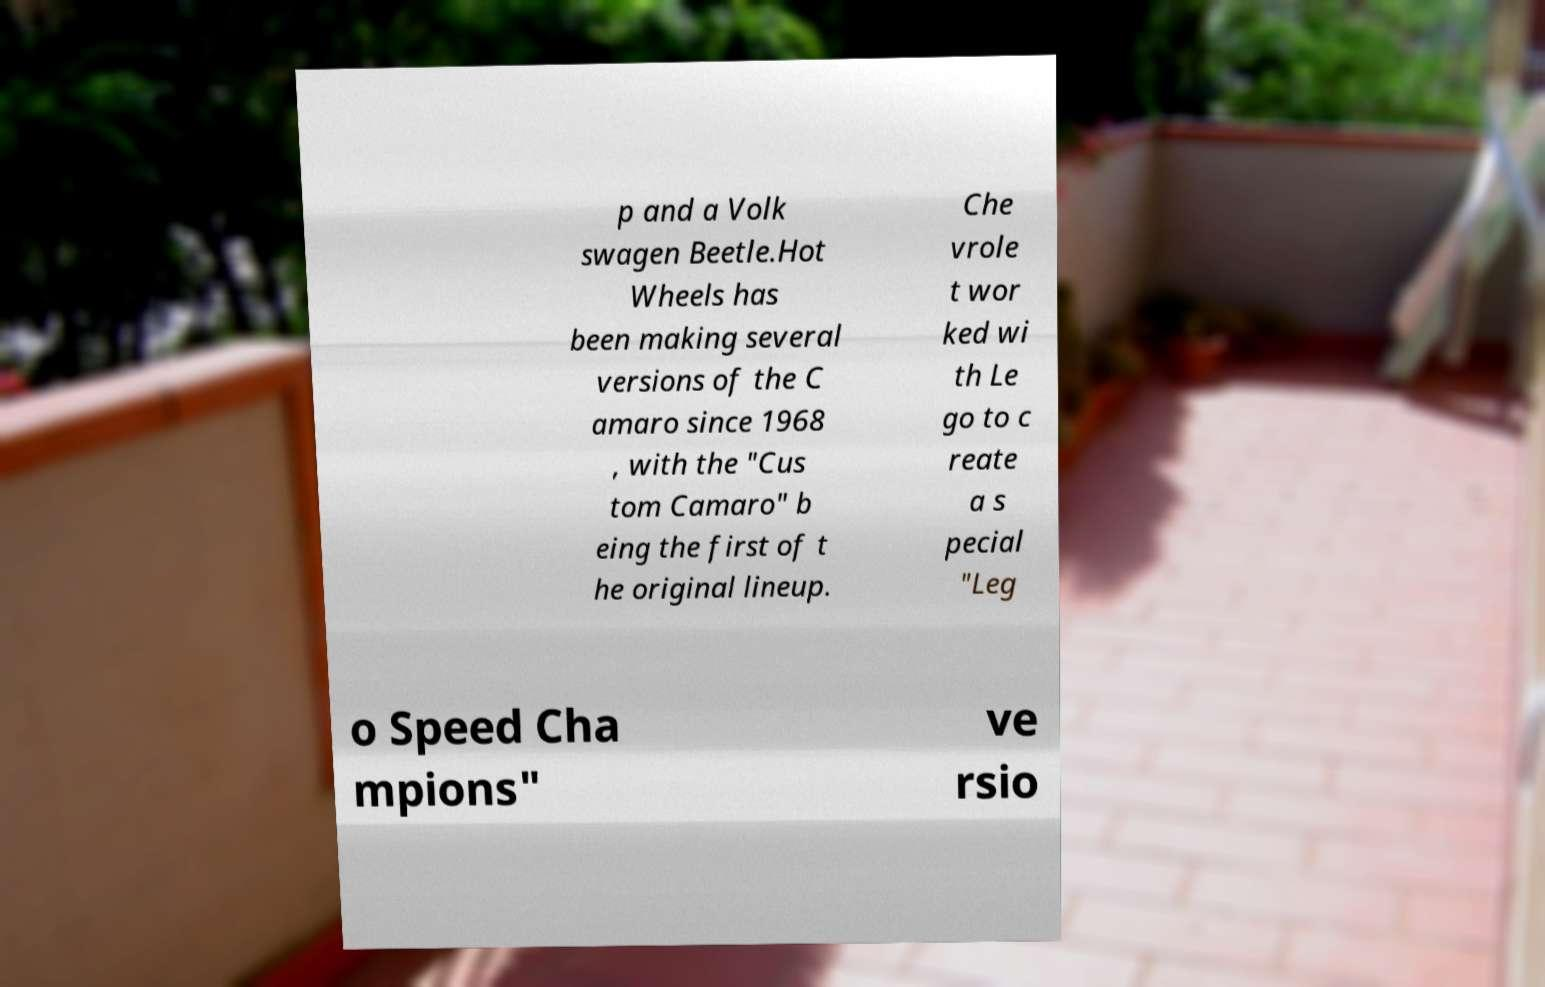Could you assist in decoding the text presented in this image and type it out clearly? p and a Volk swagen Beetle.Hot Wheels has been making several versions of the C amaro since 1968 , with the "Cus tom Camaro" b eing the first of t he original lineup. Che vrole t wor ked wi th Le go to c reate a s pecial "Leg o Speed Cha mpions" ve rsio 